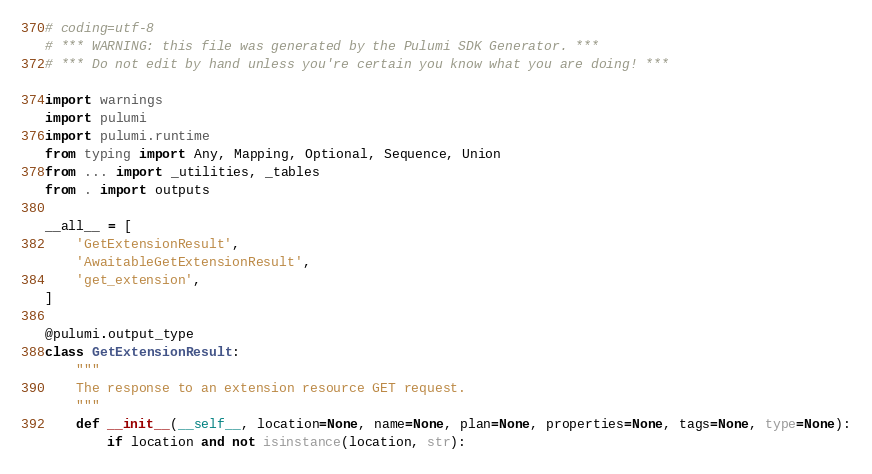<code> <loc_0><loc_0><loc_500><loc_500><_Python_># coding=utf-8
# *** WARNING: this file was generated by the Pulumi SDK Generator. ***
# *** Do not edit by hand unless you're certain you know what you are doing! ***

import warnings
import pulumi
import pulumi.runtime
from typing import Any, Mapping, Optional, Sequence, Union
from ... import _utilities, _tables
from . import outputs

__all__ = [
    'GetExtensionResult',
    'AwaitableGetExtensionResult',
    'get_extension',
]

@pulumi.output_type
class GetExtensionResult:
    """
    The response to an extension resource GET request.
    """
    def __init__(__self__, location=None, name=None, plan=None, properties=None, tags=None, type=None):
        if location and not isinstance(location, str):</code> 